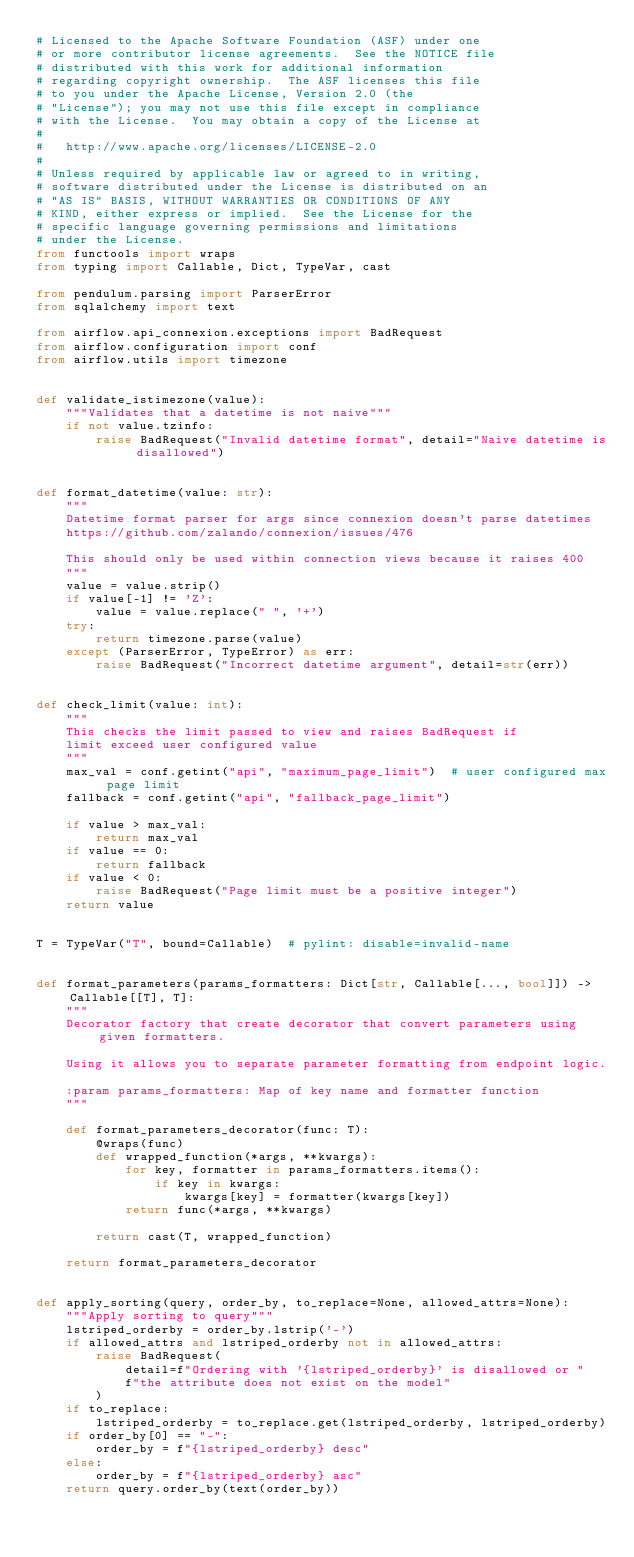<code> <loc_0><loc_0><loc_500><loc_500><_Python_># Licensed to the Apache Software Foundation (ASF) under one
# or more contributor license agreements.  See the NOTICE file
# distributed with this work for additional information
# regarding copyright ownership.  The ASF licenses this file
# to you under the Apache License, Version 2.0 (the
# "License"); you may not use this file except in compliance
# with the License.  You may obtain a copy of the License at
#
#   http://www.apache.org/licenses/LICENSE-2.0
#
# Unless required by applicable law or agreed to in writing,
# software distributed under the License is distributed on an
# "AS IS" BASIS, WITHOUT WARRANTIES OR CONDITIONS OF ANY
# KIND, either express or implied.  See the License for the
# specific language governing permissions and limitations
# under the License.
from functools import wraps
from typing import Callable, Dict, TypeVar, cast

from pendulum.parsing import ParserError
from sqlalchemy import text

from airflow.api_connexion.exceptions import BadRequest
from airflow.configuration import conf
from airflow.utils import timezone


def validate_istimezone(value):
    """Validates that a datetime is not naive"""
    if not value.tzinfo:
        raise BadRequest("Invalid datetime format", detail="Naive datetime is disallowed")


def format_datetime(value: str):
    """
    Datetime format parser for args since connexion doesn't parse datetimes
    https://github.com/zalando/connexion/issues/476

    This should only be used within connection views because it raises 400
    """
    value = value.strip()
    if value[-1] != 'Z':
        value = value.replace(" ", '+')
    try:
        return timezone.parse(value)
    except (ParserError, TypeError) as err:
        raise BadRequest("Incorrect datetime argument", detail=str(err))


def check_limit(value: int):
    """
    This checks the limit passed to view and raises BadRequest if
    limit exceed user configured value
    """
    max_val = conf.getint("api", "maximum_page_limit")  # user configured max page limit
    fallback = conf.getint("api", "fallback_page_limit")

    if value > max_val:
        return max_val
    if value == 0:
        return fallback
    if value < 0:
        raise BadRequest("Page limit must be a positive integer")
    return value


T = TypeVar("T", bound=Callable)  # pylint: disable=invalid-name


def format_parameters(params_formatters: Dict[str, Callable[..., bool]]) -> Callable[[T], T]:
    """
    Decorator factory that create decorator that convert parameters using given formatters.

    Using it allows you to separate parameter formatting from endpoint logic.

    :param params_formatters: Map of key name and formatter function
    """

    def format_parameters_decorator(func: T):
        @wraps(func)
        def wrapped_function(*args, **kwargs):
            for key, formatter in params_formatters.items():
                if key in kwargs:
                    kwargs[key] = formatter(kwargs[key])
            return func(*args, **kwargs)

        return cast(T, wrapped_function)

    return format_parameters_decorator


def apply_sorting(query, order_by, to_replace=None, allowed_attrs=None):
    """Apply sorting to query"""
    lstriped_orderby = order_by.lstrip('-')
    if allowed_attrs and lstriped_orderby not in allowed_attrs:
        raise BadRequest(
            detail=f"Ordering with '{lstriped_orderby}' is disallowed or "
            f"the attribute does not exist on the model"
        )
    if to_replace:
        lstriped_orderby = to_replace.get(lstriped_orderby, lstriped_orderby)
    if order_by[0] == "-":
        order_by = f"{lstriped_orderby} desc"
    else:
        order_by = f"{lstriped_orderby} asc"
    return query.order_by(text(order_by))
</code> 